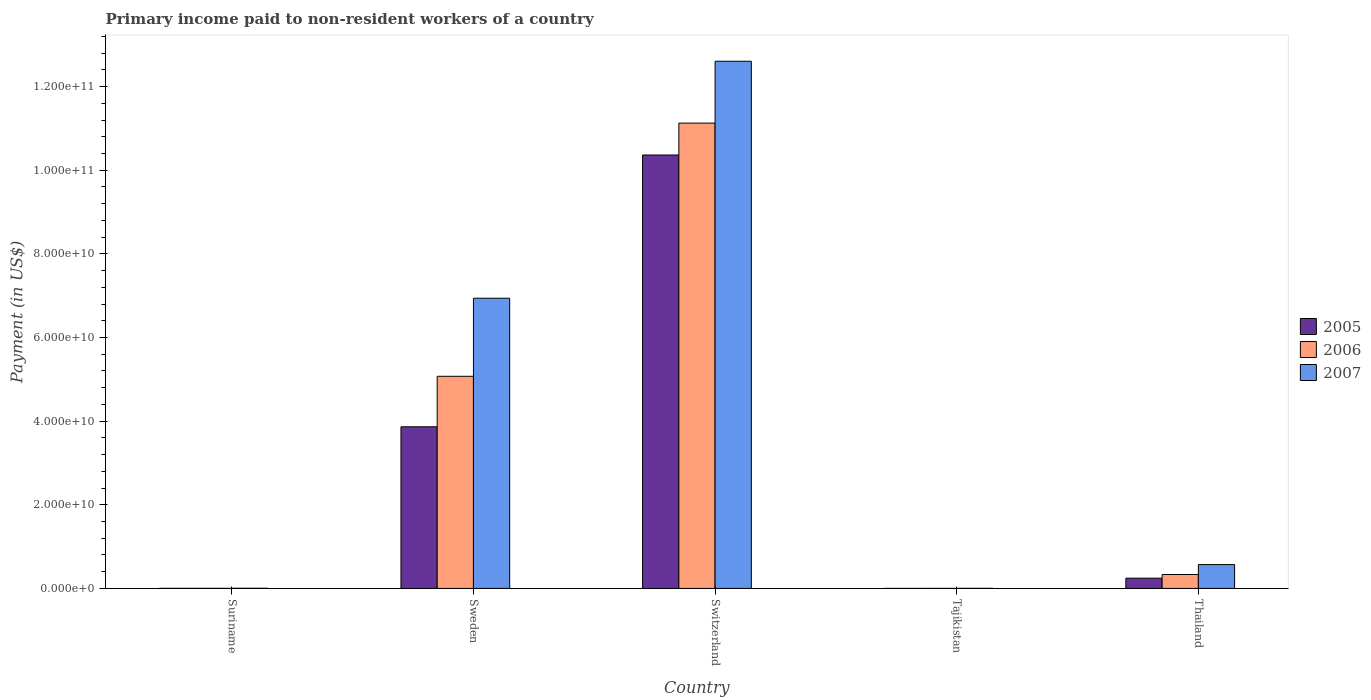How many different coloured bars are there?
Provide a succinct answer. 3. How many groups of bars are there?
Make the answer very short. 5. How many bars are there on the 1st tick from the left?
Your answer should be compact. 3. What is the label of the 3rd group of bars from the left?
Keep it short and to the point. Switzerland. In how many cases, is the number of bars for a given country not equal to the number of legend labels?
Your response must be concise. 0. What is the amount paid to workers in 2007 in Thailand?
Your response must be concise. 5.70e+09. Across all countries, what is the maximum amount paid to workers in 2007?
Offer a very short reply. 1.26e+11. Across all countries, what is the minimum amount paid to workers in 2007?
Your response must be concise. 2.24e+07. In which country was the amount paid to workers in 2006 maximum?
Your answer should be very brief. Switzerland. In which country was the amount paid to workers in 2007 minimum?
Give a very brief answer. Tajikistan. What is the total amount paid to workers in 2007 in the graph?
Keep it short and to the point. 2.01e+11. What is the difference between the amount paid to workers in 2007 in Suriname and that in Tajikistan?
Keep it short and to the point. 2.12e+07. What is the difference between the amount paid to workers in 2005 in Thailand and the amount paid to workers in 2007 in Sweden?
Give a very brief answer. -6.69e+1. What is the average amount paid to workers in 2005 per country?
Offer a very short reply. 2.90e+1. What is the difference between the amount paid to workers of/in 2007 and amount paid to workers of/in 2005 in Sweden?
Your response must be concise. 3.07e+1. In how many countries, is the amount paid to workers in 2006 greater than 36000000000 US$?
Provide a succinct answer. 2. What is the ratio of the amount paid to workers in 2007 in Sweden to that in Tajikistan?
Provide a succinct answer. 3094.29. Is the amount paid to workers in 2007 in Sweden less than that in Thailand?
Your answer should be very brief. No. What is the difference between the highest and the second highest amount paid to workers in 2006?
Your answer should be very brief. 6.05e+1. What is the difference between the highest and the lowest amount paid to workers in 2007?
Provide a short and direct response. 1.26e+11. In how many countries, is the amount paid to workers in 2005 greater than the average amount paid to workers in 2005 taken over all countries?
Keep it short and to the point. 2. What does the 3rd bar from the left in Tajikistan represents?
Your answer should be compact. 2007. Is it the case that in every country, the sum of the amount paid to workers in 2007 and amount paid to workers in 2006 is greater than the amount paid to workers in 2005?
Your answer should be very brief. Yes. How many bars are there?
Offer a very short reply. 15. Are all the bars in the graph horizontal?
Give a very brief answer. No. How many countries are there in the graph?
Keep it short and to the point. 5. Does the graph contain any zero values?
Provide a short and direct response. No. Where does the legend appear in the graph?
Make the answer very short. Center right. What is the title of the graph?
Give a very brief answer. Primary income paid to non-resident workers of a country. Does "2000" appear as one of the legend labels in the graph?
Your answer should be compact. No. What is the label or title of the Y-axis?
Your answer should be very brief. Payment (in US$). What is the Payment (in US$) of 2005 in Suriname?
Keep it short and to the point. 2.40e+07. What is the Payment (in US$) in 2006 in Suriname?
Keep it short and to the point. 2.50e+07. What is the Payment (in US$) in 2007 in Suriname?
Ensure brevity in your answer.  4.36e+07. What is the Payment (in US$) in 2005 in Sweden?
Offer a very short reply. 3.87e+1. What is the Payment (in US$) in 2006 in Sweden?
Your answer should be very brief. 5.07e+1. What is the Payment (in US$) in 2007 in Sweden?
Your answer should be very brief. 6.94e+1. What is the Payment (in US$) of 2005 in Switzerland?
Provide a short and direct response. 1.04e+11. What is the Payment (in US$) in 2006 in Switzerland?
Provide a short and direct response. 1.11e+11. What is the Payment (in US$) of 2007 in Switzerland?
Your answer should be compact. 1.26e+11. What is the Payment (in US$) of 2005 in Tajikistan?
Offer a very short reply. 9.59e+06. What is the Payment (in US$) of 2006 in Tajikistan?
Your answer should be compact. 1.24e+07. What is the Payment (in US$) of 2007 in Tajikistan?
Your response must be concise. 2.24e+07. What is the Payment (in US$) in 2005 in Thailand?
Make the answer very short. 2.45e+09. What is the Payment (in US$) in 2006 in Thailand?
Provide a succinct answer. 3.33e+09. What is the Payment (in US$) of 2007 in Thailand?
Offer a terse response. 5.70e+09. Across all countries, what is the maximum Payment (in US$) in 2005?
Your answer should be compact. 1.04e+11. Across all countries, what is the maximum Payment (in US$) in 2006?
Your answer should be very brief. 1.11e+11. Across all countries, what is the maximum Payment (in US$) of 2007?
Provide a succinct answer. 1.26e+11. Across all countries, what is the minimum Payment (in US$) in 2005?
Your response must be concise. 9.59e+06. Across all countries, what is the minimum Payment (in US$) of 2006?
Keep it short and to the point. 1.24e+07. Across all countries, what is the minimum Payment (in US$) of 2007?
Ensure brevity in your answer.  2.24e+07. What is the total Payment (in US$) in 2005 in the graph?
Provide a succinct answer. 1.45e+11. What is the total Payment (in US$) in 2006 in the graph?
Ensure brevity in your answer.  1.65e+11. What is the total Payment (in US$) of 2007 in the graph?
Provide a succinct answer. 2.01e+11. What is the difference between the Payment (in US$) in 2005 in Suriname and that in Sweden?
Offer a terse response. -3.86e+1. What is the difference between the Payment (in US$) of 2006 in Suriname and that in Sweden?
Offer a very short reply. -5.07e+1. What is the difference between the Payment (in US$) of 2007 in Suriname and that in Sweden?
Your response must be concise. -6.93e+1. What is the difference between the Payment (in US$) of 2005 in Suriname and that in Switzerland?
Offer a terse response. -1.04e+11. What is the difference between the Payment (in US$) in 2006 in Suriname and that in Switzerland?
Offer a very short reply. -1.11e+11. What is the difference between the Payment (in US$) of 2007 in Suriname and that in Switzerland?
Your answer should be compact. -1.26e+11. What is the difference between the Payment (in US$) of 2005 in Suriname and that in Tajikistan?
Provide a succinct answer. 1.44e+07. What is the difference between the Payment (in US$) in 2006 in Suriname and that in Tajikistan?
Offer a very short reply. 1.26e+07. What is the difference between the Payment (in US$) of 2007 in Suriname and that in Tajikistan?
Ensure brevity in your answer.  2.12e+07. What is the difference between the Payment (in US$) of 2005 in Suriname and that in Thailand?
Your answer should be compact. -2.43e+09. What is the difference between the Payment (in US$) in 2006 in Suriname and that in Thailand?
Your answer should be compact. -3.31e+09. What is the difference between the Payment (in US$) in 2007 in Suriname and that in Thailand?
Offer a very short reply. -5.65e+09. What is the difference between the Payment (in US$) of 2005 in Sweden and that in Switzerland?
Provide a short and direct response. -6.50e+1. What is the difference between the Payment (in US$) of 2006 in Sweden and that in Switzerland?
Keep it short and to the point. -6.05e+1. What is the difference between the Payment (in US$) of 2007 in Sweden and that in Switzerland?
Make the answer very short. -5.67e+1. What is the difference between the Payment (in US$) in 2005 in Sweden and that in Tajikistan?
Make the answer very short. 3.86e+1. What is the difference between the Payment (in US$) of 2006 in Sweden and that in Tajikistan?
Keep it short and to the point. 5.07e+1. What is the difference between the Payment (in US$) in 2007 in Sweden and that in Tajikistan?
Provide a succinct answer. 6.94e+1. What is the difference between the Payment (in US$) of 2005 in Sweden and that in Thailand?
Offer a terse response. 3.62e+1. What is the difference between the Payment (in US$) of 2006 in Sweden and that in Thailand?
Ensure brevity in your answer.  4.74e+1. What is the difference between the Payment (in US$) in 2007 in Sweden and that in Thailand?
Keep it short and to the point. 6.37e+1. What is the difference between the Payment (in US$) of 2005 in Switzerland and that in Tajikistan?
Keep it short and to the point. 1.04e+11. What is the difference between the Payment (in US$) of 2006 in Switzerland and that in Tajikistan?
Offer a terse response. 1.11e+11. What is the difference between the Payment (in US$) in 2007 in Switzerland and that in Tajikistan?
Offer a terse response. 1.26e+11. What is the difference between the Payment (in US$) in 2005 in Switzerland and that in Thailand?
Offer a terse response. 1.01e+11. What is the difference between the Payment (in US$) of 2006 in Switzerland and that in Thailand?
Provide a succinct answer. 1.08e+11. What is the difference between the Payment (in US$) of 2007 in Switzerland and that in Thailand?
Provide a succinct answer. 1.20e+11. What is the difference between the Payment (in US$) of 2005 in Tajikistan and that in Thailand?
Your answer should be very brief. -2.44e+09. What is the difference between the Payment (in US$) of 2006 in Tajikistan and that in Thailand?
Provide a short and direct response. -3.32e+09. What is the difference between the Payment (in US$) in 2007 in Tajikistan and that in Thailand?
Provide a short and direct response. -5.68e+09. What is the difference between the Payment (in US$) of 2005 in Suriname and the Payment (in US$) of 2006 in Sweden?
Your answer should be compact. -5.07e+1. What is the difference between the Payment (in US$) of 2005 in Suriname and the Payment (in US$) of 2007 in Sweden?
Offer a very short reply. -6.94e+1. What is the difference between the Payment (in US$) in 2006 in Suriname and the Payment (in US$) in 2007 in Sweden?
Your answer should be compact. -6.94e+1. What is the difference between the Payment (in US$) in 2005 in Suriname and the Payment (in US$) in 2006 in Switzerland?
Ensure brevity in your answer.  -1.11e+11. What is the difference between the Payment (in US$) in 2005 in Suriname and the Payment (in US$) in 2007 in Switzerland?
Provide a short and direct response. -1.26e+11. What is the difference between the Payment (in US$) of 2006 in Suriname and the Payment (in US$) of 2007 in Switzerland?
Your answer should be very brief. -1.26e+11. What is the difference between the Payment (in US$) in 2005 in Suriname and the Payment (in US$) in 2006 in Tajikistan?
Your answer should be very brief. 1.16e+07. What is the difference between the Payment (in US$) in 2005 in Suriname and the Payment (in US$) in 2007 in Tajikistan?
Keep it short and to the point. 1.58e+06. What is the difference between the Payment (in US$) of 2006 in Suriname and the Payment (in US$) of 2007 in Tajikistan?
Ensure brevity in your answer.  2.58e+06. What is the difference between the Payment (in US$) in 2005 in Suriname and the Payment (in US$) in 2006 in Thailand?
Provide a short and direct response. -3.31e+09. What is the difference between the Payment (in US$) in 2005 in Suriname and the Payment (in US$) in 2007 in Thailand?
Provide a succinct answer. -5.67e+09. What is the difference between the Payment (in US$) of 2006 in Suriname and the Payment (in US$) of 2007 in Thailand?
Your response must be concise. -5.67e+09. What is the difference between the Payment (in US$) of 2005 in Sweden and the Payment (in US$) of 2006 in Switzerland?
Offer a very short reply. -7.26e+1. What is the difference between the Payment (in US$) in 2005 in Sweden and the Payment (in US$) in 2007 in Switzerland?
Your answer should be compact. -8.74e+1. What is the difference between the Payment (in US$) in 2006 in Sweden and the Payment (in US$) in 2007 in Switzerland?
Ensure brevity in your answer.  -7.53e+1. What is the difference between the Payment (in US$) in 2005 in Sweden and the Payment (in US$) in 2006 in Tajikistan?
Your answer should be compact. 3.86e+1. What is the difference between the Payment (in US$) of 2005 in Sweden and the Payment (in US$) of 2007 in Tajikistan?
Offer a terse response. 3.86e+1. What is the difference between the Payment (in US$) of 2006 in Sweden and the Payment (in US$) of 2007 in Tajikistan?
Your response must be concise. 5.07e+1. What is the difference between the Payment (in US$) of 2005 in Sweden and the Payment (in US$) of 2006 in Thailand?
Keep it short and to the point. 3.53e+1. What is the difference between the Payment (in US$) in 2005 in Sweden and the Payment (in US$) in 2007 in Thailand?
Give a very brief answer. 3.30e+1. What is the difference between the Payment (in US$) in 2006 in Sweden and the Payment (in US$) in 2007 in Thailand?
Provide a succinct answer. 4.50e+1. What is the difference between the Payment (in US$) in 2005 in Switzerland and the Payment (in US$) in 2006 in Tajikistan?
Your response must be concise. 1.04e+11. What is the difference between the Payment (in US$) in 2005 in Switzerland and the Payment (in US$) in 2007 in Tajikistan?
Ensure brevity in your answer.  1.04e+11. What is the difference between the Payment (in US$) in 2006 in Switzerland and the Payment (in US$) in 2007 in Tajikistan?
Provide a short and direct response. 1.11e+11. What is the difference between the Payment (in US$) of 2005 in Switzerland and the Payment (in US$) of 2006 in Thailand?
Offer a very short reply. 1.00e+11. What is the difference between the Payment (in US$) of 2005 in Switzerland and the Payment (in US$) of 2007 in Thailand?
Offer a terse response. 9.79e+1. What is the difference between the Payment (in US$) of 2006 in Switzerland and the Payment (in US$) of 2007 in Thailand?
Offer a terse response. 1.06e+11. What is the difference between the Payment (in US$) of 2005 in Tajikistan and the Payment (in US$) of 2006 in Thailand?
Provide a short and direct response. -3.32e+09. What is the difference between the Payment (in US$) in 2005 in Tajikistan and the Payment (in US$) in 2007 in Thailand?
Your answer should be compact. -5.69e+09. What is the difference between the Payment (in US$) in 2006 in Tajikistan and the Payment (in US$) in 2007 in Thailand?
Your answer should be compact. -5.69e+09. What is the average Payment (in US$) in 2005 per country?
Offer a terse response. 2.90e+1. What is the average Payment (in US$) of 2006 per country?
Offer a terse response. 3.31e+1. What is the average Payment (in US$) of 2007 per country?
Offer a terse response. 4.02e+1. What is the difference between the Payment (in US$) in 2005 and Payment (in US$) in 2006 in Suriname?
Offer a terse response. -1.00e+06. What is the difference between the Payment (in US$) in 2005 and Payment (in US$) in 2007 in Suriname?
Keep it short and to the point. -1.96e+07. What is the difference between the Payment (in US$) of 2006 and Payment (in US$) of 2007 in Suriname?
Offer a terse response. -1.86e+07. What is the difference between the Payment (in US$) in 2005 and Payment (in US$) in 2006 in Sweden?
Give a very brief answer. -1.21e+1. What is the difference between the Payment (in US$) of 2005 and Payment (in US$) of 2007 in Sweden?
Your response must be concise. -3.07e+1. What is the difference between the Payment (in US$) of 2006 and Payment (in US$) of 2007 in Sweden?
Offer a very short reply. -1.87e+1. What is the difference between the Payment (in US$) of 2005 and Payment (in US$) of 2006 in Switzerland?
Provide a short and direct response. -7.63e+09. What is the difference between the Payment (in US$) of 2005 and Payment (in US$) of 2007 in Switzerland?
Your answer should be very brief. -2.24e+1. What is the difference between the Payment (in US$) of 2006 and Payment (in US$) of 2007 in Switzerland?
Offer a terse response. -1.48e+1. What is the difference between the Payment (in US$) in 2005 and Payment (in US$) in 2006 in Tajikistan?
Ensure brevity in your answer.  -2.84e+06. What is the difference between the Payment (in US$) of 2005 and Payment (in US$) of 2007 in Tajikistan?
Give a very brief answer. -1.28e+07. What is the difference between the Payment (in US$) of 2006 and Payment (in US$) of 2007 in Tajikistan?
Your answer should be compact. -1.00e+07. What is the difference between the Payment (in US$) of 2005 and Payment (in US$) of 2006 in Thailand?
Offer a terse response. -8.80e+08. What is the difference between the Payment (in US$) of 2005 and Payment (in US$) of 2007 in Thailand?
Offer a terse response. -3.24e+09. What is the difference between the Payment (in US$) of 2006 and Payment (in US$) of 2007 in Thailand?
Offer a very short reply. -2.37e+09. What is the ratio of the Payment (in US$) of 2005 in Suriname to that in Sweden?
Your response must be concise. 0. What is the ratio of the Payment (in US$) in 2006 in Suriname to that in Sweden?
Provide a succinct answer. 0. What is the ratio of the Payment (in US$) in 2007 in Suriname to that in Sweden?
Offer a terse response. 0. What is the ratio of the Payment (in US$) of 2007 in Suriname to that in Switzerland?
Your response must be concise. 0. What is the ratio of the Payment (in US$) of 2005 in Suriname to that in Tajikistan?
Your answer should be compact. 2.5. What is the ratio of the Payment (in US$) in 2006 in Suriname to that in Tajikistan?
Offer a very short reply. 2.01. What is the ratio of the Payment (in US$) of 2007 in Suriname to that in Tajikistan?
Your answer should be very brief. 1.94. What is the ratio of the Payment (in US$) of 2005 in Suriname to that in Thailand?
Give a very brief answer. 0.01. What is the ratio of the Payment (in US$) in 2006 in Suriname to that in Thailand?
Make the answer very short. 0.01. What is the ratio of the Payment (in US$) of 2007 in Suriname to that in Thailand?
Provide a short and direct response. 0.01. What is the ratio of the Payment (in US$) in 2005 in Sweden to that in Switzerland?
Provide a short and direct response. 0.37. What is the ratio of the Payment (in US$) in 2006 in Sweden to that in Switzerland?
Your answer should be very brief. 0.46. What is the ratio of the Payment (in US$) of 2007 in Sweden to that in Switzerland?
Provide a succinct answer. 0.55. What is the ratio of the Payment (in US$) of 2005 in Sweden to that in Tajikistan?
Provide a succinct answer. 4031.97. What is the ratio of the Payment (in US$) in 2006 in Sweden to that in Tajikistan?
Your response must be concise. 4081.57. What is the ratio of the Payment (in US$) of 2007 in Sweden to that in Tajikistan?
Offer a terse response. 3094.29. What is the ratio of the Payment (in US$) in 2005 in Sweden to that in Thailand?
Provide a succinct answer. 15.76. What is the ratio of the Payment (in US$) in 2006 in Sweden to that in Thailand?
Offer a terse response. 15.22. What is the ratio of the Payment (in US$) of 2007 in Sweden to that in Thailand?
Provide a short and direct response. 12.18. What is the ratio of the Payment (in US$) of 2005 in Switzerland to that in Tajikistan?
Your response must be concise. 1.08e+04. What is the ratio of the Payment (in US$) of 2006 in Switzerland to that in Tajikistan?
Give a very brief answer. 8953.06. What is the ratio of the Payment (in US$) in 2007 in Switzerland to that in Tajikistan?
Offer a terse response. 5621.28. What is the ratio of the Payment (in US$) in 2005 in Switzerland to that in Thailand?
Your answer should be very brief. 42.25. What is the ratio of the Payment (in US$) in 2006 in Switzerland to that in Thailand?
Your answer should be very brief. 33.39. What is the ratio of the Payment (in US$) of 2007 in Switzerland to that in Thailand?
Offer a terse response. 22.12. What is the ratio of the Payment (in US$) of 2005 in Tajikistan to that in Thailand?
Keep it short and to the point. 0. What is the ratio of the Payment (in US$) of 2006 in Tajikistan to that in Thailand?
Provide a short and direct response. 0. What is the ratio of the Payment (in US$) of 2007 in Tajikistan to that in Thailand?
Your answer should be compact. 0. What is the difference between the highest and the second highest Payment (in US$) in 2005?
Provide a succinct answer. 6.50e+1. What is the difference between the highest and the second highest Payment (in US$) of 2006?
Provide a short and direct response. 6.05e+1. What is the difference between the highest and the second highest Payment (in US$) of 2007?
Provide a succinct answer. 5.67e+1. What is the difference between the highest and the lowest Payment (in US$) in 2005?
Make the answer very short. 1.04e+11. What is the difference between the highest and the lowest Payment (in US$) in 2006?
Your answer should be compact. 1.11e+11. What is the difference between the highest and the lowest Payment (in US$) of 2007?
Give a very brief answer. 1.26e+11. 